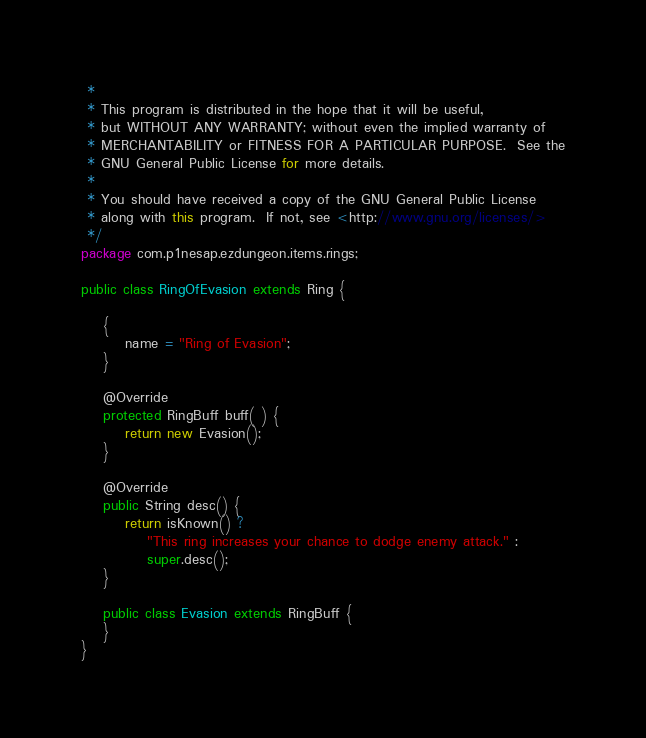Convert code to text. <code><loc_0><loc_0><loc_500><loc_500><_Java_> *
 * This program is distributed in the hope that it will be useful,
 * but WITHOUT ANY WARRANTY; without even the implied warranty of
 * MERCHANTABILITY or FITNESS FOR A PARTICULAR PURPOSE.  See the
 * GNU General Public License for more details.
 *
 * You should have received a copy of the GNU General Public License
 * along with this program.  If not, see <http://www.gnu.org/licenses/>
 */
package com.p1nesap.ezdungeon.items.rings;

public class RingOfEvasion extends Ring {

	{
		name = "Ring of Evasion";
	}
	
	@Override
	protected RingBuff buff( ) {
		return new Evasion();
	}
	
	@Override
	public String desc() {
		return isKnown() ?
			"This ring increases your chance to dodge enemy attack." :
			super.desc();
	}
	
	public class Evasion extends RingBuff {	
	}
}
</code> 